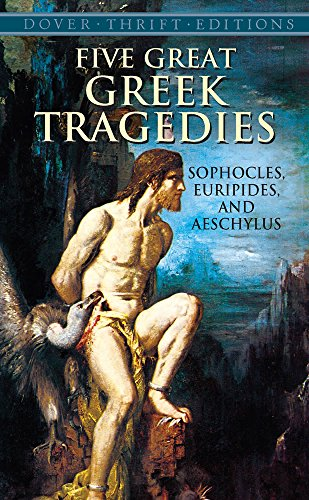Who are the other authors featured in this collection apart from Sophocles? The collection also includes works by Euripides and Aeschylus, making it a rich showcase of Ancient Greek drama. 